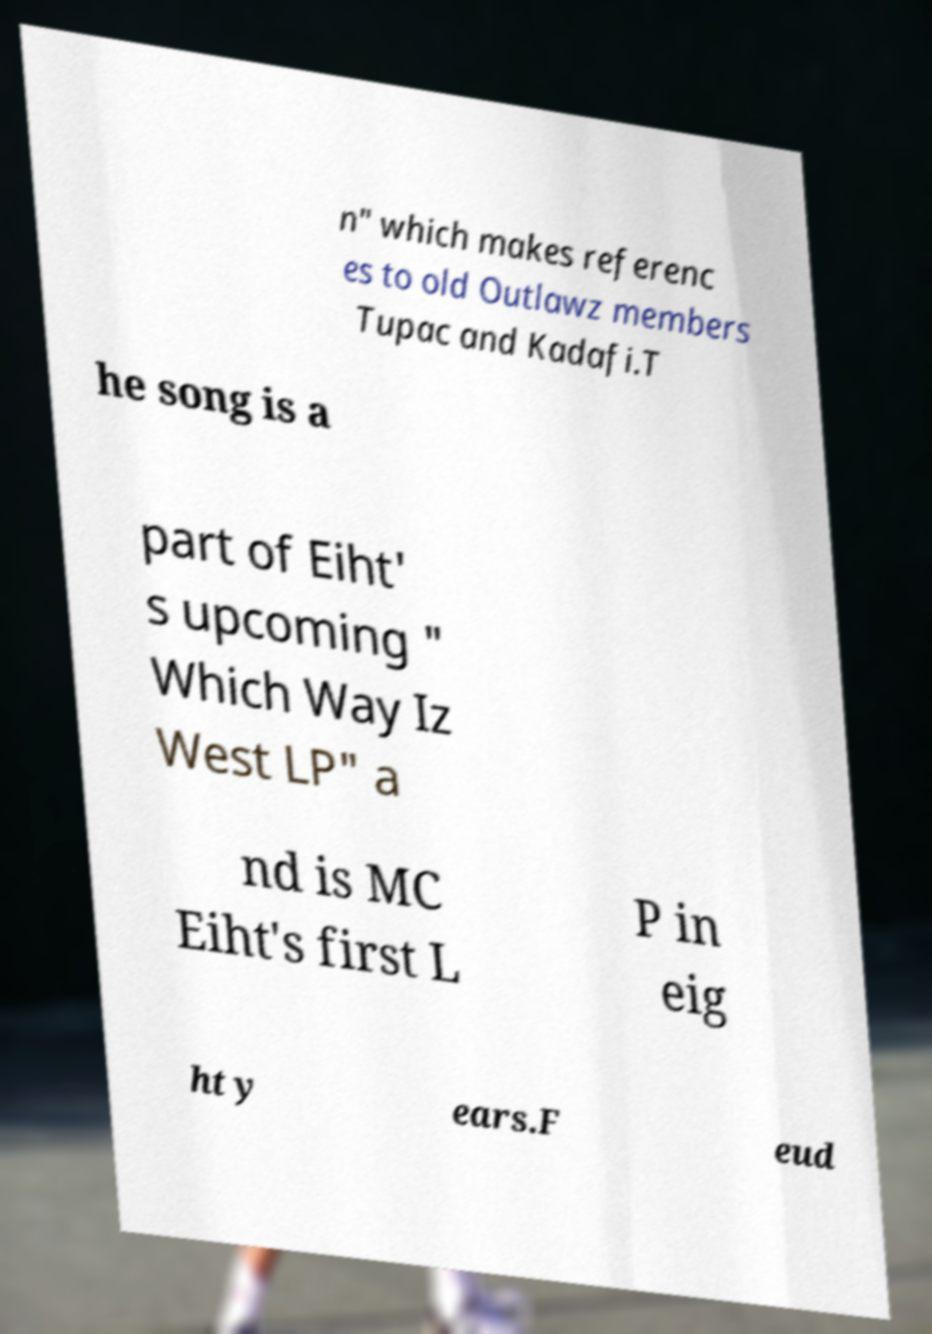Could you extract and type out the text from this image? n" which makes referenc es to old Outlawz members Tupac and Kadafi.T he song is a part of Eiht' s upcoming " Which Way Iz West LP" a nd is MC Eiht's first L P in eig ht y ears.F eud 